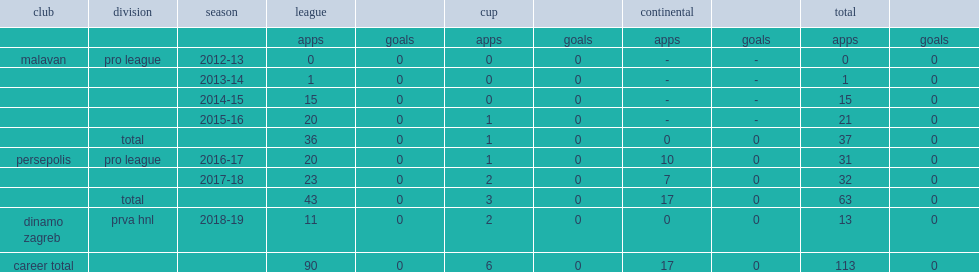Which club did sadegh moharrami play for in 2013-14? Malavan. 